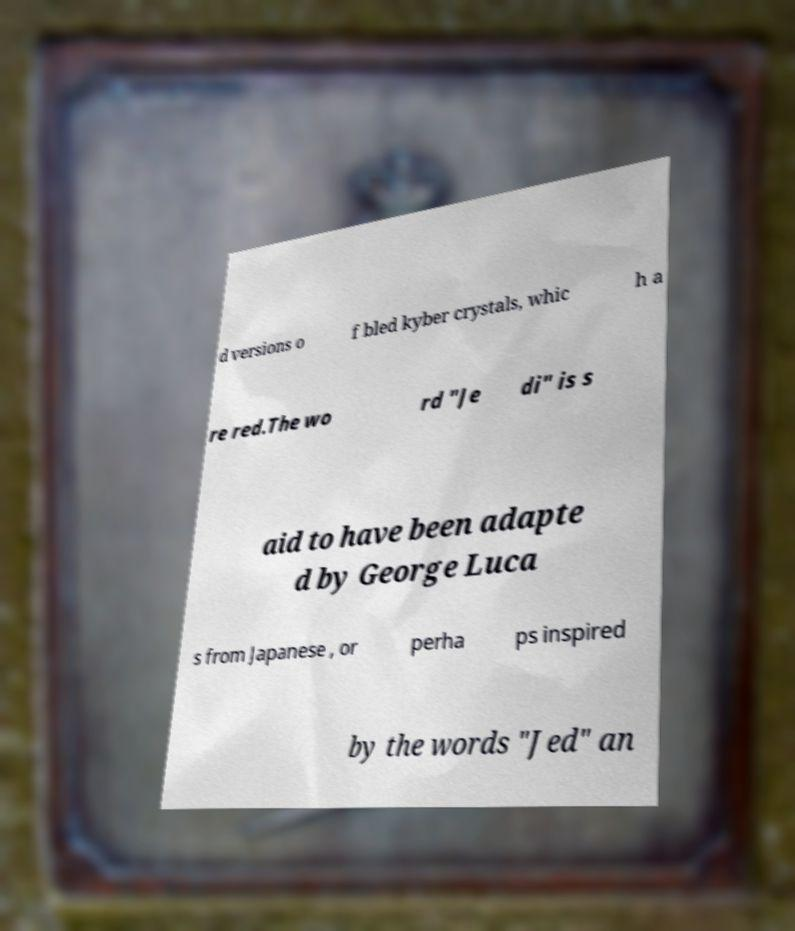Could you extract and type out the text from this image? d versions o f bled kyber crystals, whic h a re red.The wo rd "Je di" is s aid to have been adapte d by George Luca s from Japanese , or perha ps inspired by the words "Jed" an 